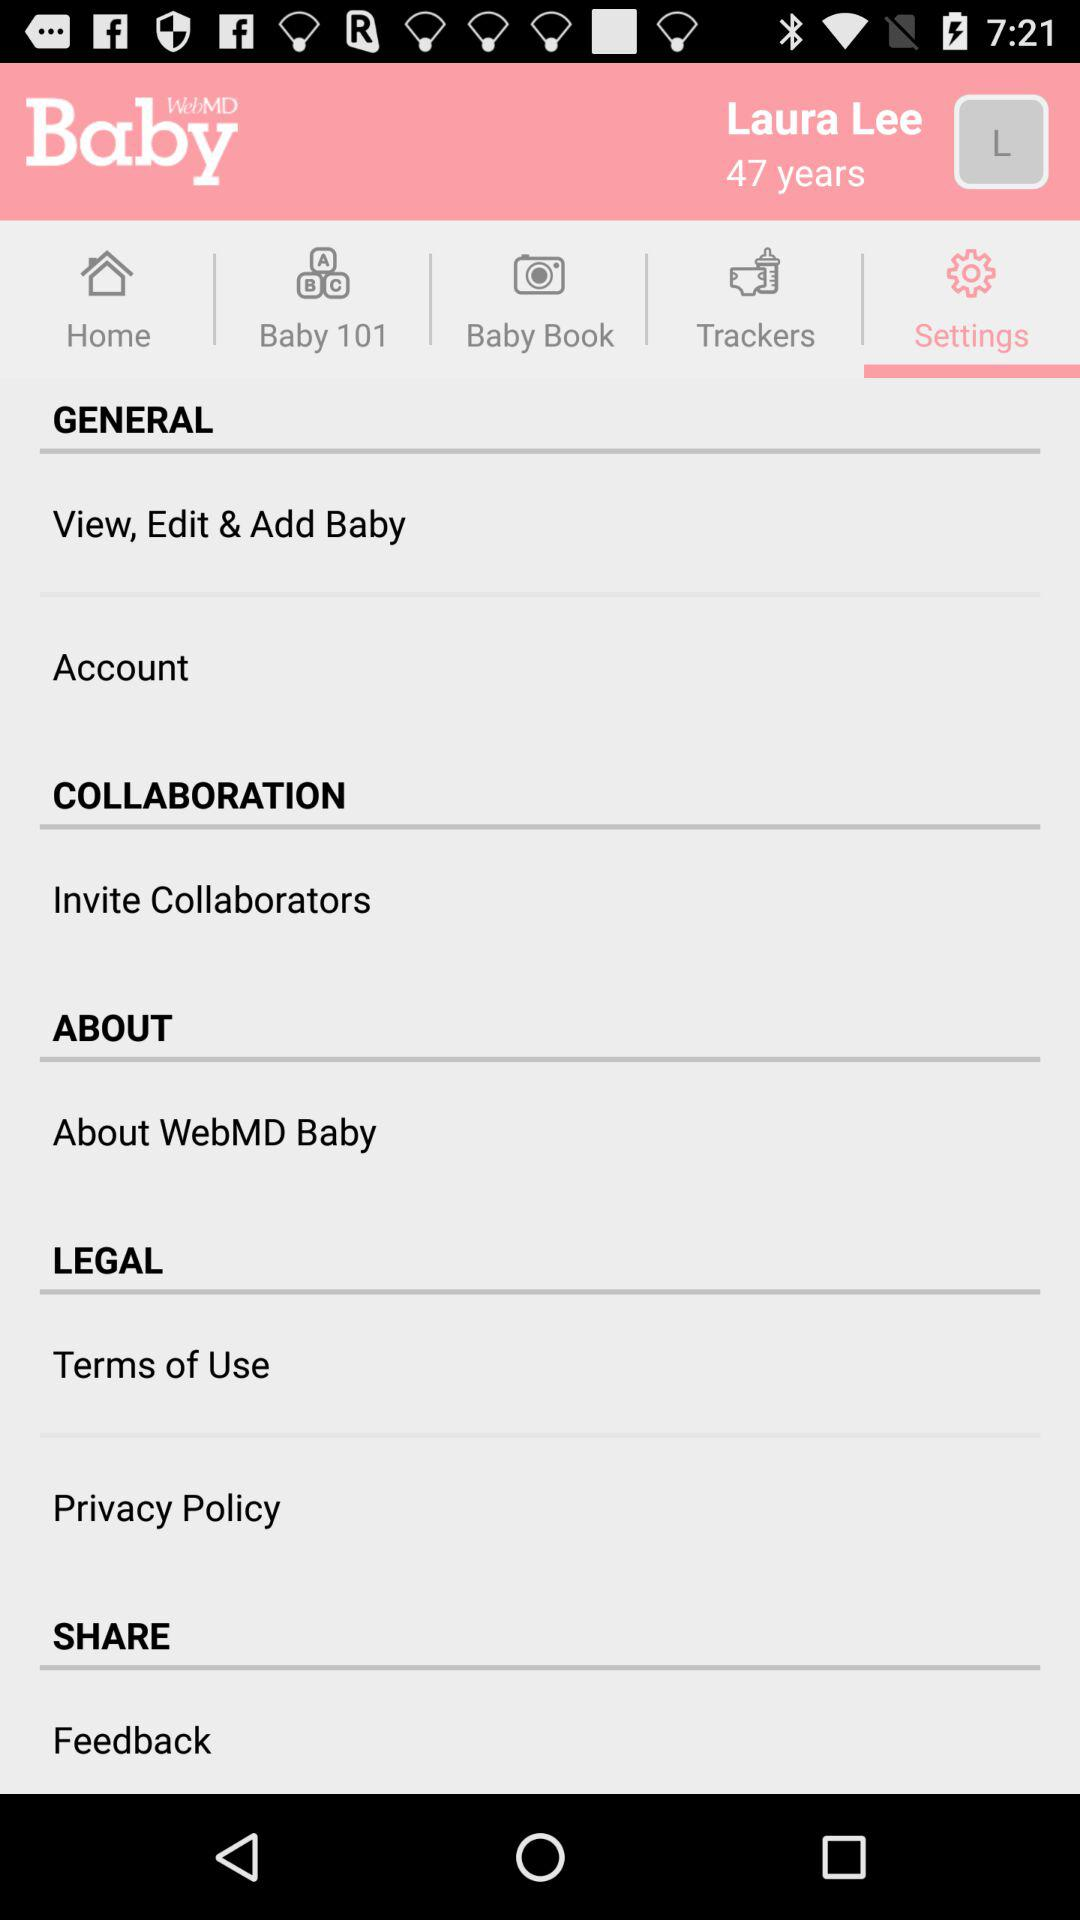Which tab is selected? The selected tab is "Settings". 